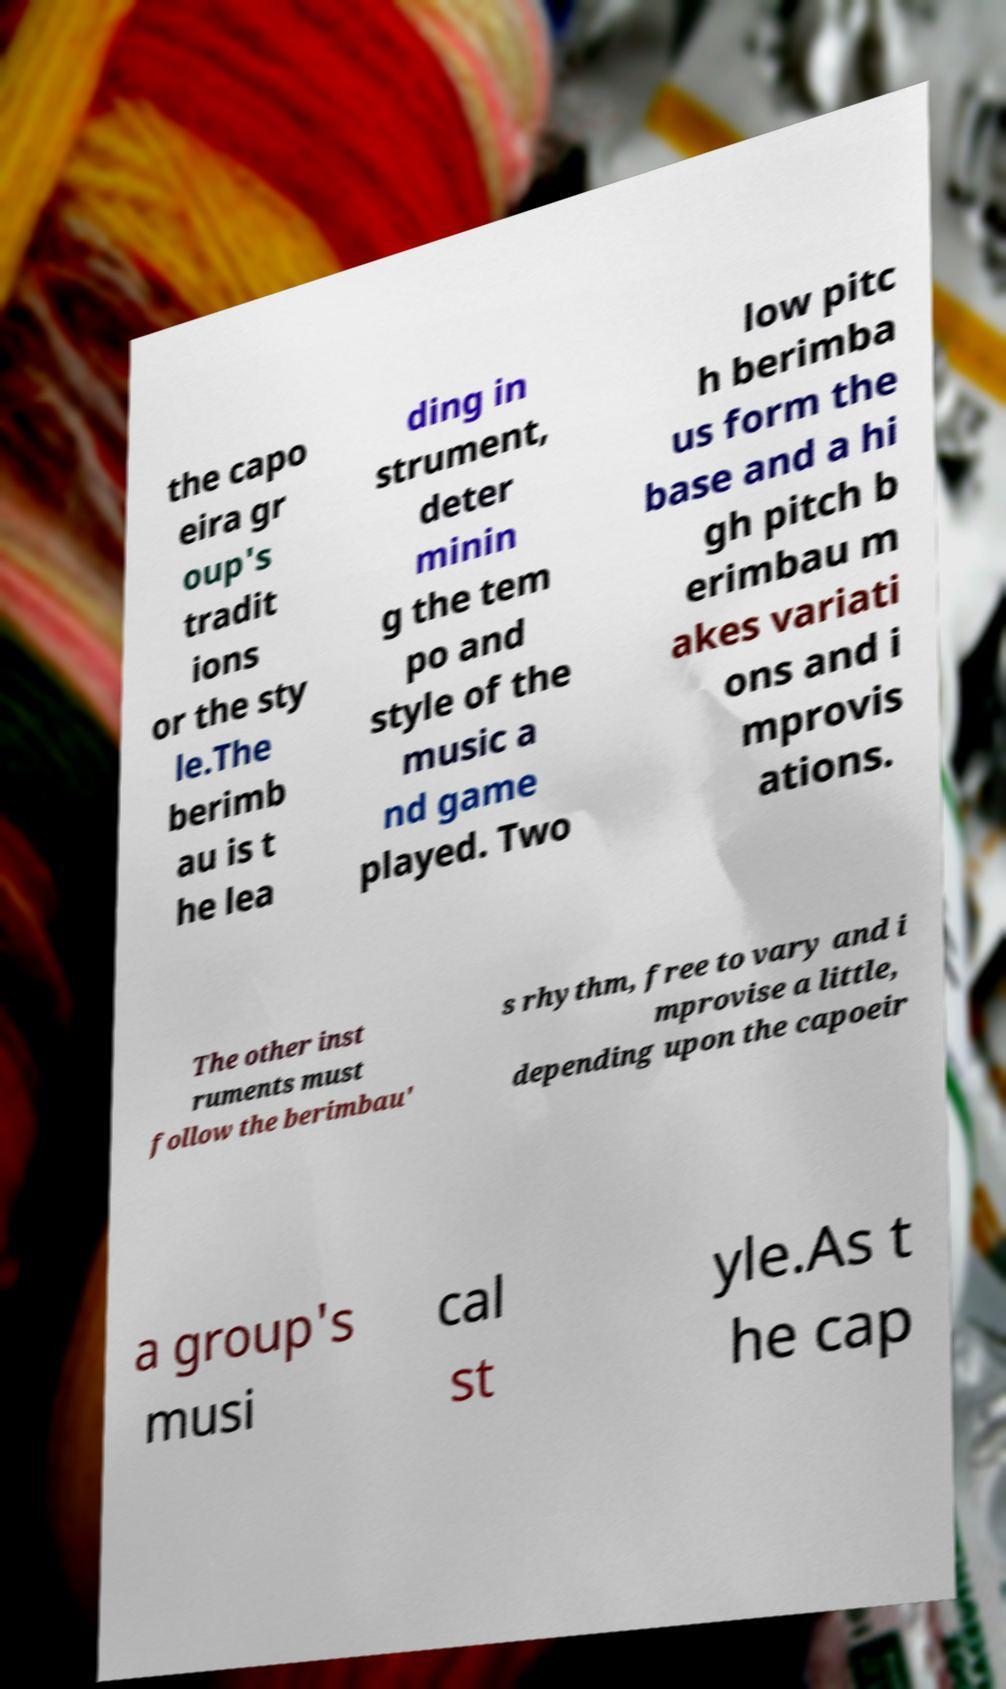For documentation purposes, I need the text within this image transcribed. Could you provide that? the capo eira gr oup's tradit ions or the sty le.The berimb au is t he lea ding in strument, deter minin g the tem po and style of the music a nd game played. Two low pitc h berimba us form the base and a hi gh pitch b erimbau m akes variati ons and i mprovis ations. The other inst ruments must follow the berimbau' s rhythm, free to vary and i mprovise a little, depending upon the capoeir a group's musi cal st yle.As t he cap 